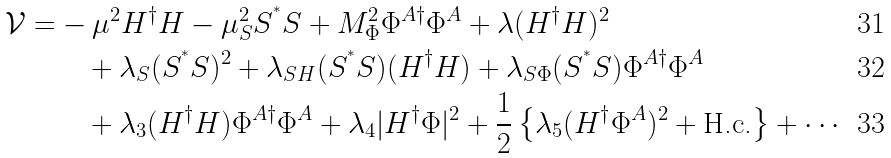<formula> <loc_0><loc_0><loc_500><loc_500>\mathcal { V } = & - \mu ^ { 2 } H ^ { \dag } H - \mu _ { S } ^ { 2 } S ^ { ^ { * } } S + M _ { \Phi } ^ { 2 } \Phi ^ { A \dag } \Phi ^ { A } + \lambda ( H ^ { \dag } H ) ^ { 2 } \\ & \quad + \lambda _ { S } ( S ^ { ^ { * } } S ) ^ { 2 } + \lambda _ { S H } ( S ^ { ^ { * } } S ) ( H ^ { \dag } H ) + \lambda _ { S \Phi } ( S ^ { ^ { * } } S ) \Phi ^ { A \dag } \Phi ^ { A } \\ & \quad + \lambda _ { 3 } ( H ^ { \dag } H ) \Phi ^ { A \dag } \Phi ^ { A } + \lambda _ { 4 } | H ^ { \dag } \Phi | ^ { 2 } + \frac { 1 } { 2 } \left \{ \lambda _ { 5 } ( H ^ { \dag } \Phi ^ { A } ) ^ { 2 } + \text {H.c.} \right \} + \cdots</formula> 